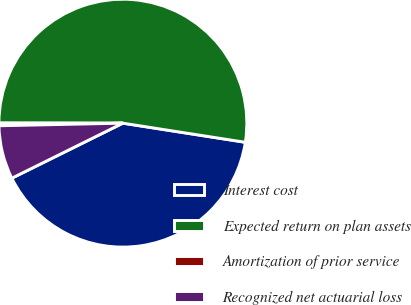Convert chart. <chart><loc_0><loc_0><loc_500><loc_500><pie_chart><fcel>Interest cost<fcel>Expected return on plan assets<fcel>Amortization of prior service<fcel>Recognized net actuarial loss<nl><fcel>40.21%<fcel>52.45%<fcel>0.35%<fcel>6.99%<nl></chart> 